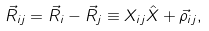Convert formula to latex. <formula><loc_0><loc_0><loc_500><loc_500>\vec { R } _ { i j } = \vec { R } _ { i } - \vec { R } _ { j } \equiv X _ { i j } \hat { X } + \vec { \rho } _ { i j } ,</formula> 